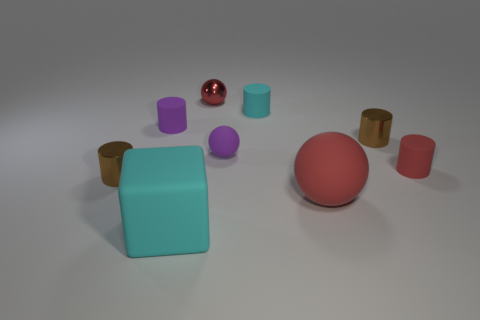Subtract all small purple rubber cylinders. How many cylinders are left? 4 Subtract all red balls. How many brown cylinders are left? 2 Subtract 2 cylinders. How many cylinders are left? 3 Subtract all cyan cylinders. How many cylinders are left? 4 Add 1 tiny gray matte cylinders. How many objects exist? 10 Subtract all blocks. How many objects are left? 8 Subtract all tiny brown metallic things. Subtract all big red matte balls. How many objects are left? 6 Add 6 big red spheres. How many big red spheres are left? 7 Add 6 small purple matte spheres. How many small purple matte spheres exist? 7 Subtract 0 blue balls. How many objects are left? 9 